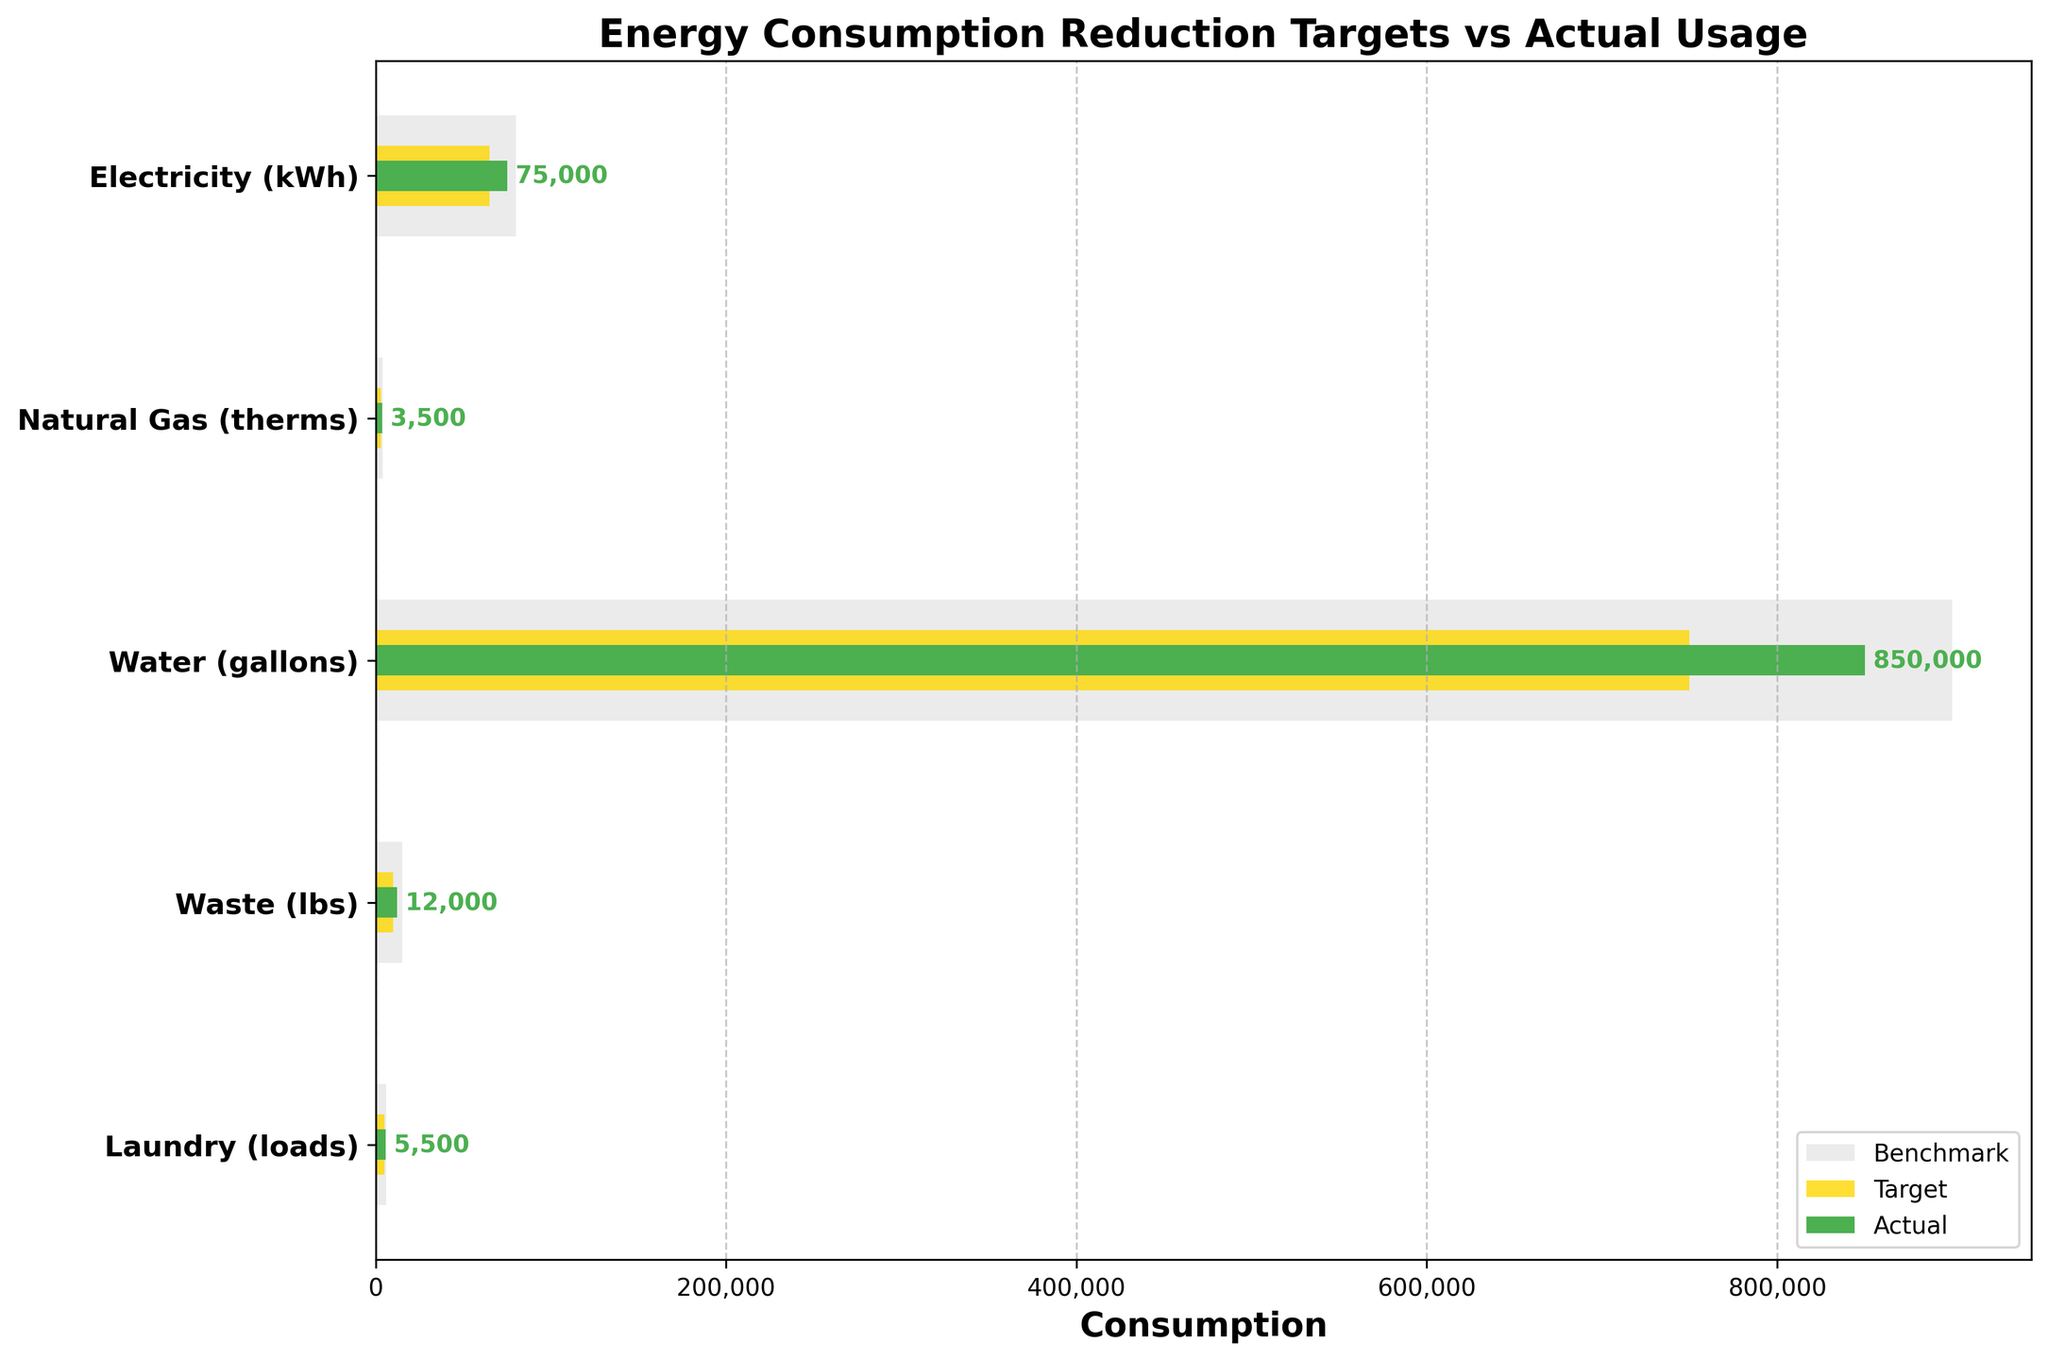What is the title of the chart? The title of a chart is usually found at the top and is used to describe the overall content of the chart. By looking at the figure, you can find the title text.
Answer: Energy Consumption Reduction Targets vs Actual Usage What does the yellow color represent in the chart? In this bullet chart, different colors represent different data elements. The legend at the lower right corner indicates that the yellow bars refer to targets.
Answer: Target Which category has the highest actual usage? To find this, compare the lengths of the green bars across all categories. The longest green bar indicates the highest actual usage. By examining the chart, "Water (gallons)" has the longest green bar.
Answer: Water (gallons) How much more electricity was actually consumed compared to its target? Observe the green bar for actual electricity usage and the yellow bar for the target. Subtract the target value from the actual value: 75,000 kWh - 65,000 kWh.
Answer: 10,000 kWh How does the actual waste compare to its target? Locate the green bar for actual waste and the yellow bar for the target. The actual waste is greater than the target waste since the green bar exceeds the yellow bar.
Answer: Greater than Which category has the closest actual usage to its target? To determine this, look for the category where the green bar (actual usage) and the yellow bar (target) are closest in length. The "Laundry (loads)" category has the closest actual usage to the target.
Answer: Laundry (loads) What is the difference between the highest and lowest benchmark values? Identify the highest and lowest benchmark values across all categories. The highest benchmark is for "Water (gallons)" at 900,000 gallons, and the lowest is for "Natural Gas (therms)" at 4,000 therms. Subtract the lowest from the highest: 900,000 - 4,000.
Answer: 896,000 In which categories did actual usage exceed the benchmark? Compare the green bars (actual usage) to the light grey bars (benchmark). No green bar exceeds its corresponding light grey bar, indicating that actual usage did not exceed benchmarks for any category.
Answer: None What is the ratio of actual to target usage for natural gas? Divide the actual value by the target value for natural gas: 3,500 therms (actual) / 3,000 therms (target).
Answer: 1.17 Which category is closest to reaching its benchmark in terms of actual usage? Compare the green bars (actual usage) to the light grey bars (benchmark) to see which category's green bar is nearest to its light grey bar. "Electricity (kWh)" is closest to reaching its benchmark.
Answer: Electricity (kWh) 